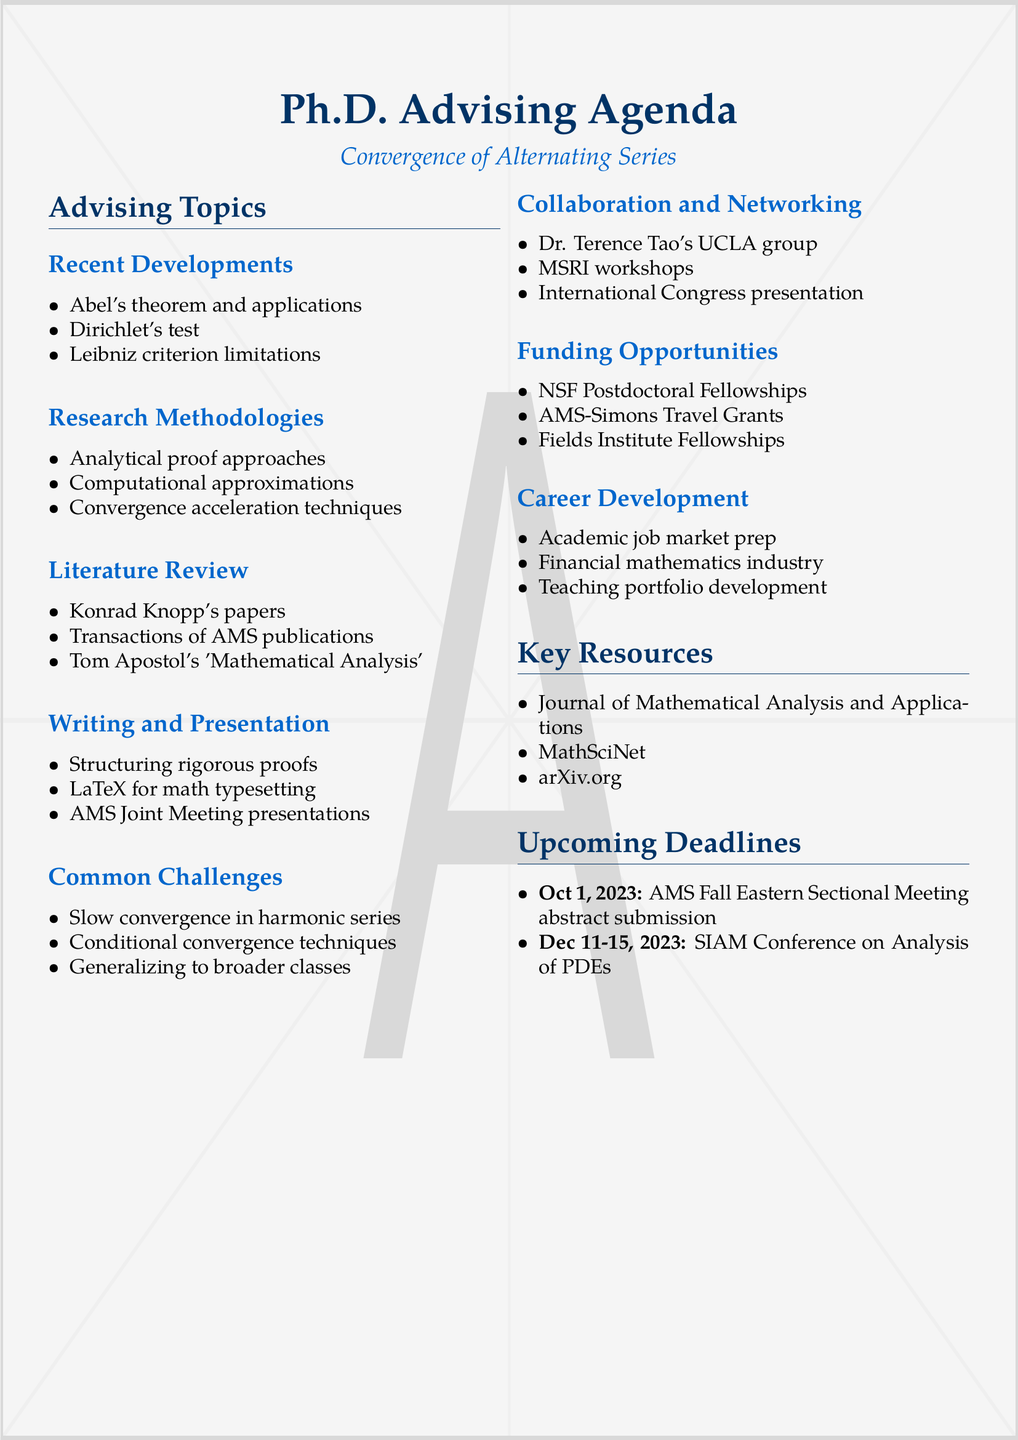What is one of the advising topics related to convergence? The document lists multiple advising topics, one being "Recent Developments in Alternating Series Convergence."
Answer: Recent Developments in Alternating Series Convergence What publication is highlighted for its key papers on alternating series? The document specifies that Konrad Knopp's papers are significant for the literature review.
Answer: Konrad Knopp's papers When is the AMS Fall Eastern Sectional Meeting scheduled? This event is mentioned in the upcoming deadlines section, scheduled for October 1, 2023.
Answer: October 1, 2023 Which test for alternating series is discussed under Recent Developments? One of the subtopics is "Dirichlet's test for alternating series."
Answer: Dirichlet's test What resource is identified as a preprint repository for research? The document notes arXiv.org as a key resource for latest research.
Answer: arXiv.org What is one common challenge addressed in the advising session? The document addresses "Dealing with slow convergence in alternating harmonic-type series" as a common challenge.
Answer: Dealing with slow convergence in alternating harmonic-type series Which fellowship is mentioned under Funding Opportunities? The document includes the "NSF Mathematical Sciences Postdoctoral Research Fellowships" as a funding opportunity.
Answer: NSF Mathematical Sciences Postdoctoral Research Fellowships What type of preparation is suggested for career development related to teaching? The document recommends "Developing a teaching portfolio focused on advanced calculus and analysis" for teaching-related preparation.
Answer: Developing a teaching portfolio focused on advanced calculus and analysis 